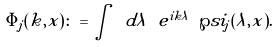Convert formula to latex. <formula><loc_0><loc_0><loc_500><loc_500>\tilde { \Phi } _ { j } ( k , x ) \colon = \int \ d \lambda \ e ^ { i k \lambda } \ \wp s i _ { j } ( \lambda , x ) .</formula> 